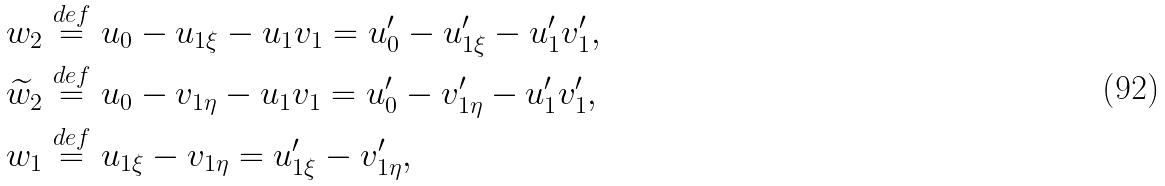Convert formula to latex. <formula><loc_0><loc_0><loc_500><loc_500>& w _ { 2 } \stackrel { d e f } { = } u _ { 0 } - u _ { 1 \xi } - u _ { 1 } v _ { 1 } = u _ { 0 } ^ { \prime } - u _ { 1 \xi } ^ { \prime } - u _ { 1 } ^ { \prime } v _ { 1 } ^ { \prime } , \\ & \widetilde { w } _ { 2 } \stackrel { d e f } { = } u _ { 0 } - v _ { 1 \eta } - u _ { 1 } v _ { 1 } = u _ { 0 } ^ { \prime } - v _ { 1 \eta } ^ { \prime } - u _ { 1 } ^ { \prime } v _ { 1 } ^ { \prime } , \\ & w _ { 1 } \stackrel { d e f } { = } u _ { 1 \xi } - v _ { 1 \eta } = u _ { 1 \xi } ^ { \prime } - v _ { 1 \eta } ^ { \prime } ,</formula> 